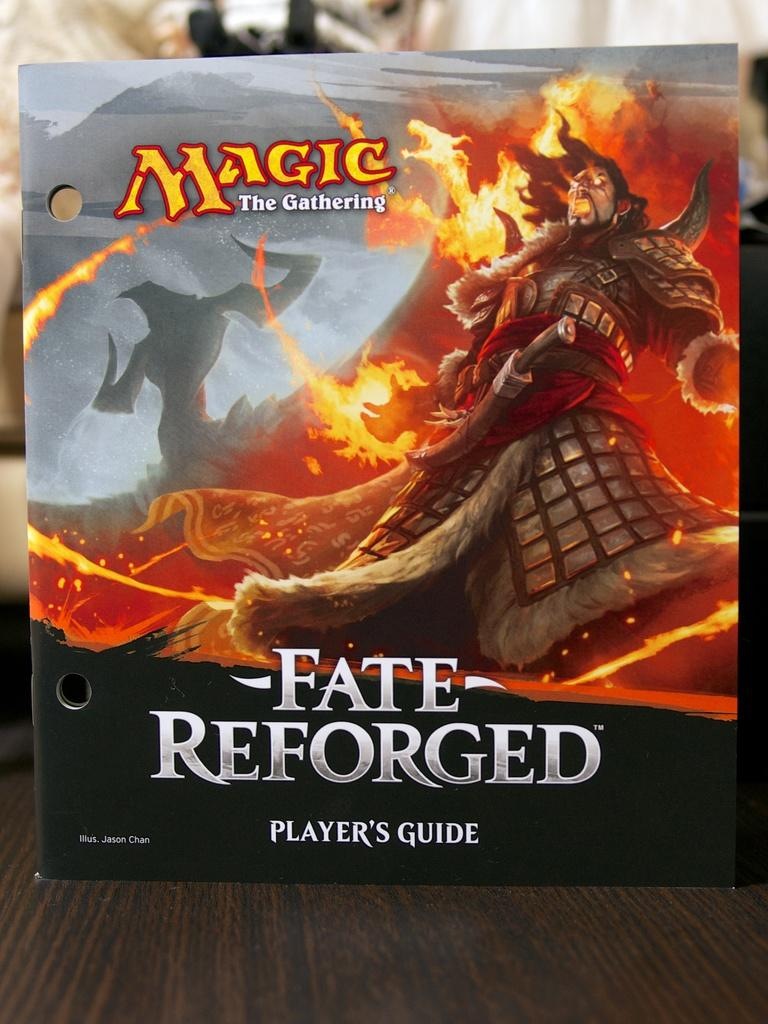<image>
Summarize the visual content of the image. The player's guide for Magic The Gathering Fate Reforged. 